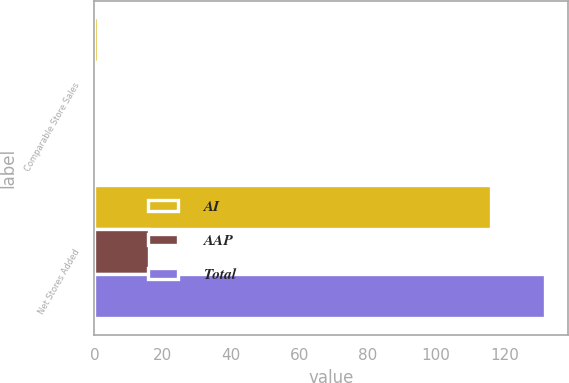Convert chart to OTSL. <chart><loc_0><loc_0><loc_500><loc_500><stacked_bar_chart><ecel><fcel>Comparable Store Sales<fcel>Net Stores Added<nl><fcel>AI<fcel>0.9<fcel>116<nl><fcel>AAP<fcel>0.8<fcel>16<nl><fcel>Total<fcel>0.8<fcel>132<nl></chart> 